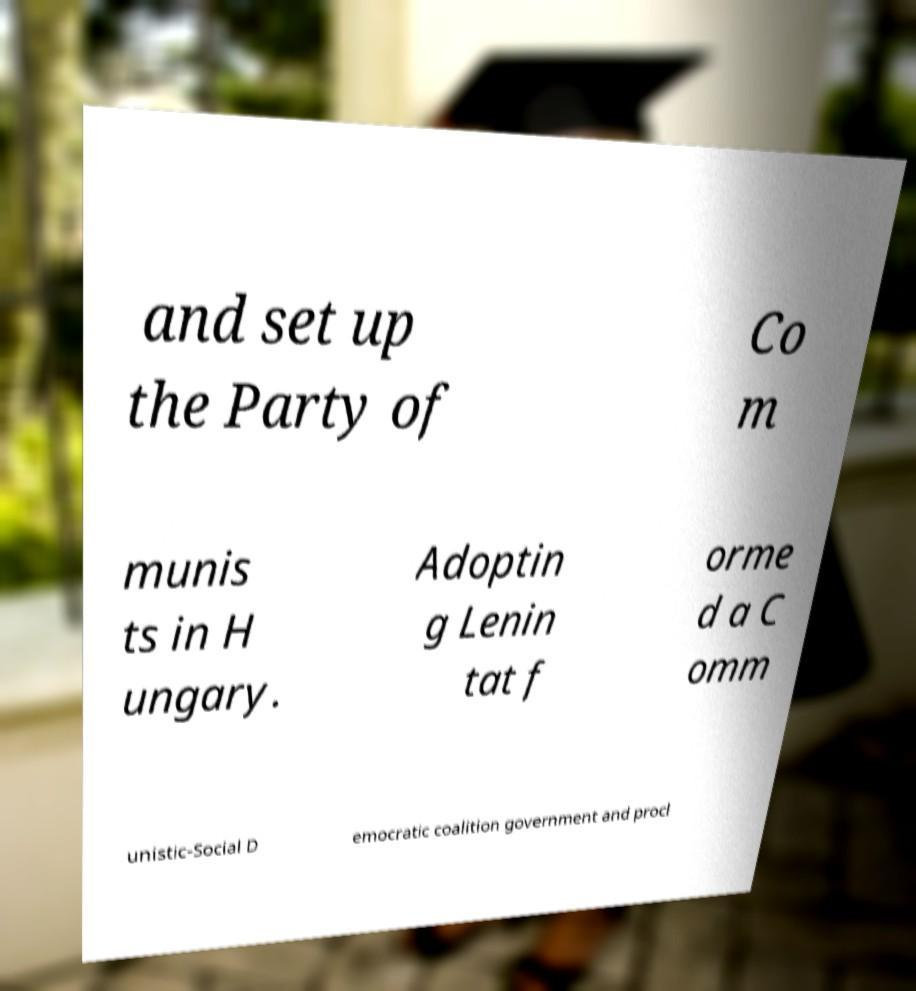I need the written content from this picture converted into text. Can you do that? and set up the Party of Co m munis ts in H ungary. Adoptin g Lenin tat f orme d a C omm unistic-Social D emocratic coalition government and procl 